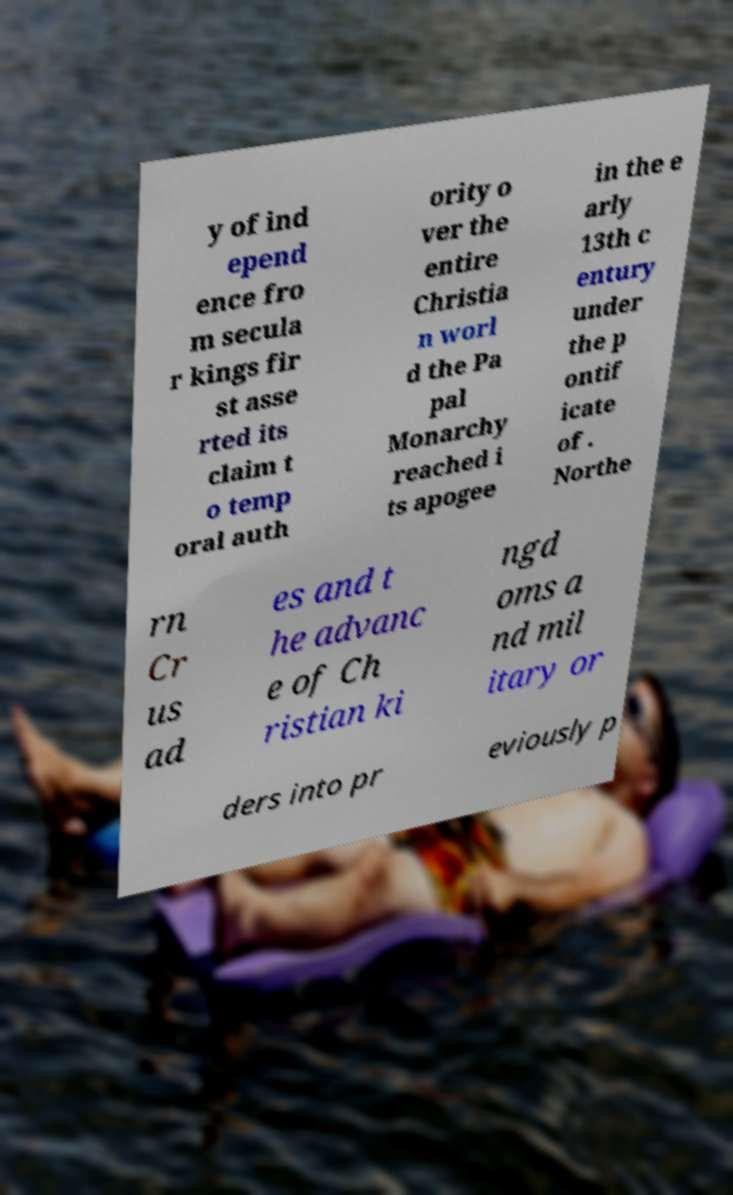For documentation purposes, I need the text within this image transcribed. Could you provide that? y of ind epend ence fro m secula r kings fir st asse rted its claim t o temp oral auth ority o ver the entire Christia n worl d the Pa pal Monarchy reached i ts apogee in the e arly 13th c entury under the p ontif icate of . Northe rn Cr us ad es and t he advanc e of Ch ristian ki ngd oms a nd mil itary or ders into pr eviously p 